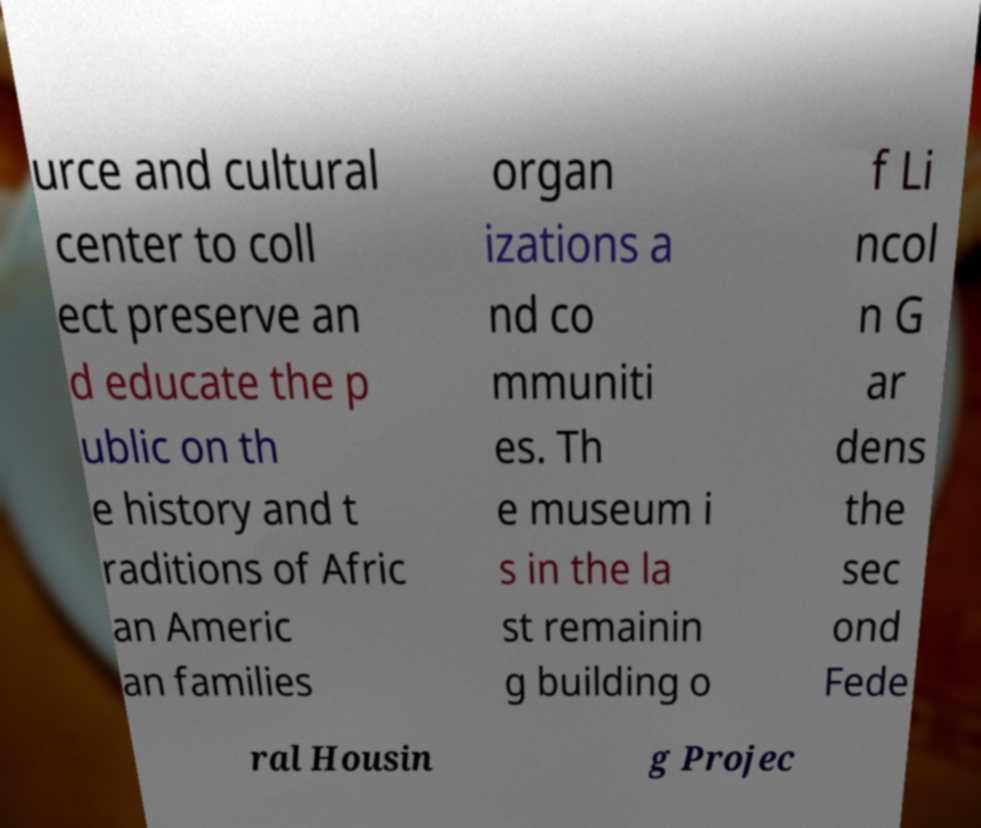For documentation purposes, I need the text within this image transcribed. Could you provide that? urce and cultural center to coll ect preserve an d educate the p ublic on th e history and t raditions of Afric an Americ an families organ izations a nd co mmuniti es. Th e museum i s in the la st remainin g building o f Li ncol n G ar dens the sec ond Fede ral Housin g Projec 